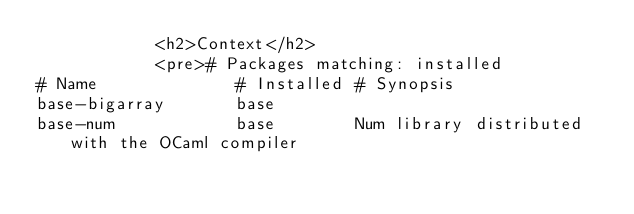<code> <loc_0><loc_0><loc_500><loc_500><_HTML_>            <h2>Context</h2>
            <pre># Packages matching: installed
# Name              # Installed # Synopsis
base-bigarray       base
base-num            base        Num library distributed with the OCaml compiler</code> 